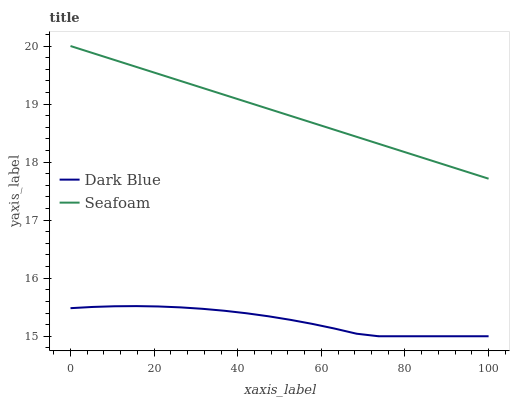Does Dark Blue have the minimum area under the curve?
Answer yes or no. Yes. Does Seafoam have the minimum area under the curve?
Answer yes or no. No. Is Seafoam the smoothest?
Answer yes or no. Yes. Is Dark Blue the roughest?
Answer yes or no. Yes. Is Seafoam the roughest?
Answer yes or no. No. Does Seafoam have the lowest value?
Answer yes or no. No. Is Dark Blue less than Seafoam?
Answer yes or no. Yes. Is Seafoam greater than Dark Blue?
Answer yes or no. Yes. Does Dark Blue intersect Seafoam?
Answer yes or no. No. 